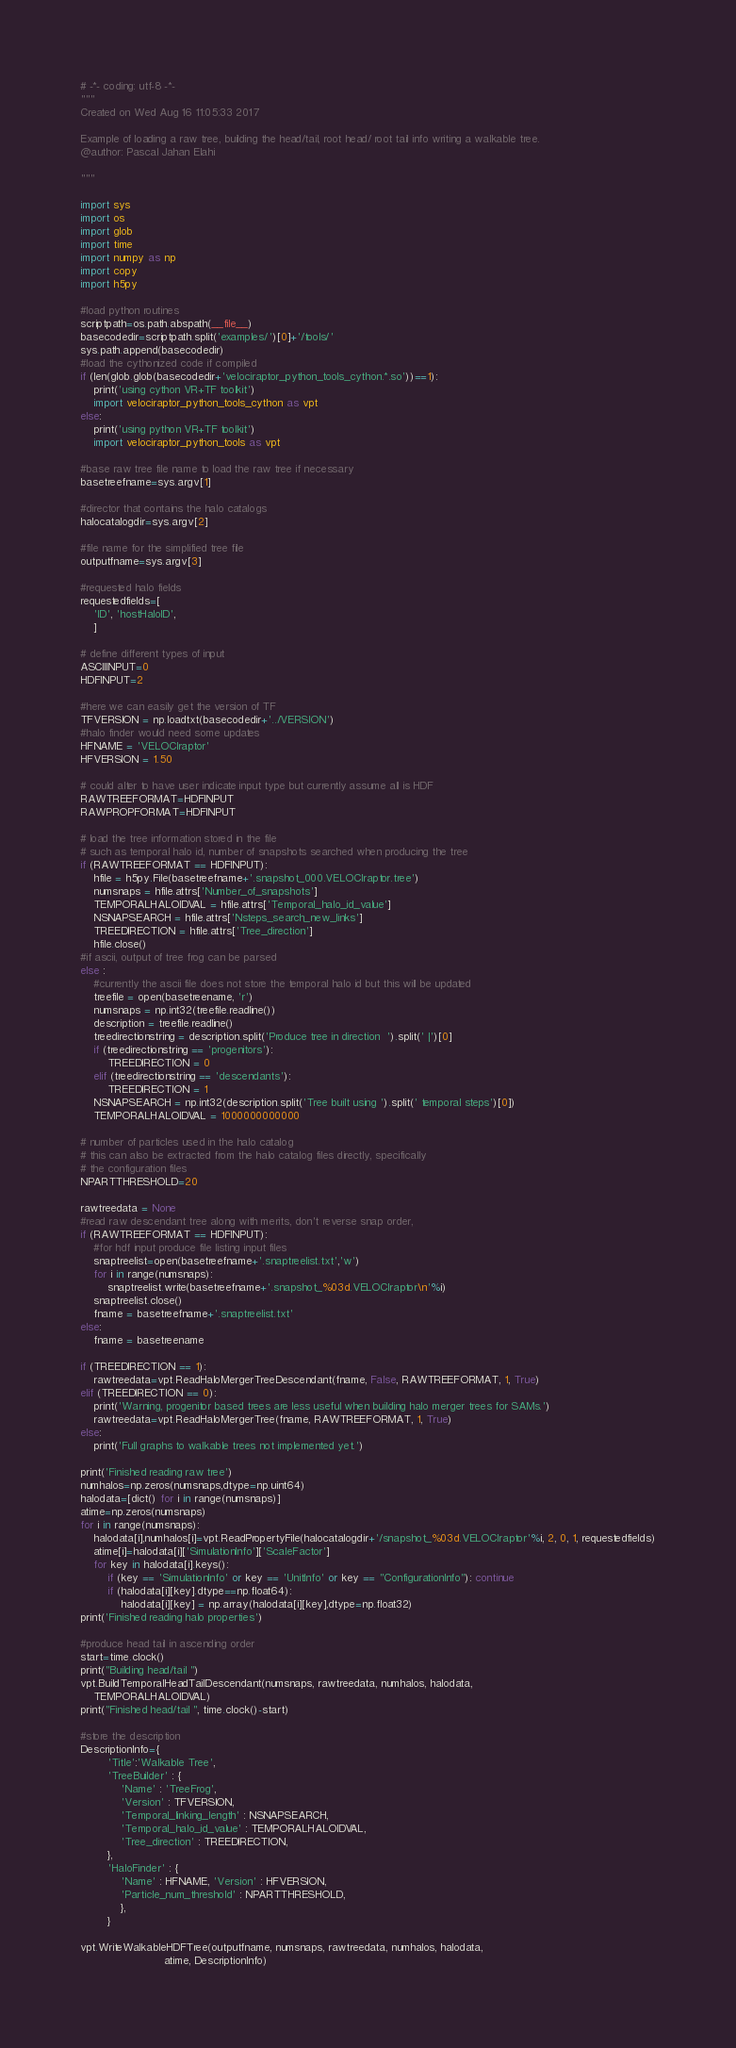<code> <loc_0><loc_0><loc_500><loc_500><_Python_># -*- coding: utf-8 -*-
"""
Created on Wed Aug 16 11:05:33 2017

Example of loading a raw tree, building the head/tail, root head/ root tail info writing a walkable tree.
@author: Pascal Jahan Elahi

"""

import sys
import os
import glob
import time
import numpy as np
import copy
import h5py

#load python routines
scriptpath=os.path.abspath(__file__)
basecodedir=scriptpath.split('examples/')[0]+'/tools/'
sys.path.append(basecodedir)
#load the cythonized code if compiled
if (len(glob.glob(basecodedir+'velociraptor_python_tools_cython.*.so'))==1):
    print('using cython VR+TF toolkit')
    import velociraptor_python_tools_cython as vpt
else:
    print('using python VR+TF toolkit')
    import velociraptor_python_tools as vpt

#base raw tree file name to load the raw tree if necessary
basetreefname=sys.argv[1]

#director that contains the halo catalogs
halocatalogdir=sys.argv[2]

#file name for the simplified tree file
outputfname=sys.argv[3]

#requested halo fields
requestedfields=[
    'ID', 'hostHaloID',
    ]

# define different types of input
ASCIIINPUT=0
HDFINPUT=2

#here we can easily get the version of TF
TFVERSION = np.loadtxt(basecodedir+'../VERSION')
#halo finder would need some updates
HFNAME = 'VELOCIraptor'
HFVERSION = 1.50

# could alter to have user indicate input type but currently assume all is HDF
RAWTREEFORMAT=HDFINPUT
RAWPROPFORMAT=HDFINPUT

# load the tree information stored in the file
# such as temporal halo id, number of snapshots searched when producing the tree
if (RAWTREEFORMAT == HDFINPUT):
    hfile = h5py.File(basetreefname+'.snapshot_000.VELOCIraptor.tree')
    numsnaps = hfile.attrs['Number_of_snapshots']
    TEMPORALHALOIDVAL = hfile.attrs['Temporal_halo_id_value']
    NSNAPSEARCH = hfile.attrs['Nsteps_search_new_links']
    TREEDIRECTION = hfile.attrs['Tree_direction']
    hfile.close()
#if ascii, output of tree frog can be parsed
else :
    #currently the ascii file does not store the temporal halo id but this will be updated
    treefile = open(basetreename, 'r')
    numsnaps = np.int32(treefile.readline())
    description = treefile.readline()
    treedirectionstring = description.split('Produce tree in direction  ').split(' |')[0]
    if (treedirectionstring == 'progenitors'):
        TREEDIRECTION = 0
    elif (treedirectionstring == 'descendants'):
        TREEDIRECTION = 1
    NSNAPSEARCH = np.int32(description.split('Tree built using ').split(' temporal steps')[0])
    TEMPORALHALOIDVAL = 1000000000000

# number of particles used in the halo catalog
# this can also be extracted from the halo catalog files directly, specifically
# the configuration files
NPARTTHRESHOLD=20

rawtreedata = None
#read raw descendant tree along with merits, don't reverse snap order,
if (RAWTREEFORMAT == HDFINPUT):
    #for hdf input produce file listing input files
    snaptreelist=open(basetreefname+'.snaptreelist.txt','w')
    for i in range(numsnaps):
        snaptreelist.write(basetreefname+'.snapshot_%03d.VELOCIraptor\n'%i)
    snaptreelist.close()
    fname = basetreefname+'.snaptreelist.txt'
else:
    fname = basetreename

if (TREEDIRECTION == 1):
    rawtreedata=vpt.ReadHaloMergerTreeDescendant(fname, False, RAWTREEFORMAT, 1, True)
elif (TREEDIRECTION == 0):
    print('Warning, progenitor based trees are less useful when building halo merger trees for SAMs.')
    rawtreedata=vpt.ReadHaloMergerTree(fname, RAWTREEFORMAT, 1, True)
else:
    print('Full graphs to walkable trees not implemented yet.')

print('Finished reading raw tree')
numhalos=np.zeros(numsnaps,dtype=np.uint64)
halodata=[dict() for i in range(numsnaps)]
atime=np.zeros(numsnaps)
for i in range(numsnaps):
    halodata[i],numhalos[i]=vpt.ReadPropertyFile(halocatalogdir+'/snapshot_%03d.VELOCIraptor'%i, 2, 0, 1, requestedfields)
    atime[i]=halodata[i]['SimulationInfo']['ScaleFactor']
    for key in halodata[i].keys():
        if (key == 'SimulationInfo' or key == 'UnitInfo' or key == "ConfigurationInfo"): continue
        if (halodata[i][key].dtype==np.float64):
            halodata[i][key] = np.array(halodata[i][key],dtype=np.float32)
print('Finished reading halo properties')

#produce head tail in ascending order
start=time.clock()
print("Building head/tail ")
vpt.BuildTemporalHeadTailDescendant(numsnaps, rawtreedata, numhalos, halodata,
    TEMPORALHALOIDVAL)
print("Finished head/tail ", time.clock()-start)

#store the description
DescriptionInfo={
        'Title':'Walkable Tree',
        'TreeBuilder' : {
            'Name' : 'TreeFrog',
            'Version' : TFVERSION,
            'Temporal_linking_length' : NSNAPSEARCH,
            'Temporal_halo_id_value' : TEMPORALHALOIDVAL,
            'Tree_direction' : TREEDIRECTION,
        },
        'HaloFinder' : {
            'Name' : HFNAME, 'Version' : HFVERSION,
            'Particle_num_threshold' : NPARTTHRESHOLD,
            },
        }

vpt.WriteWalkableHDFTree(outputfname, numsnaps, rawtreedata, numhalos, halodata,
                         atime, DescriptionInfo)
</code> 